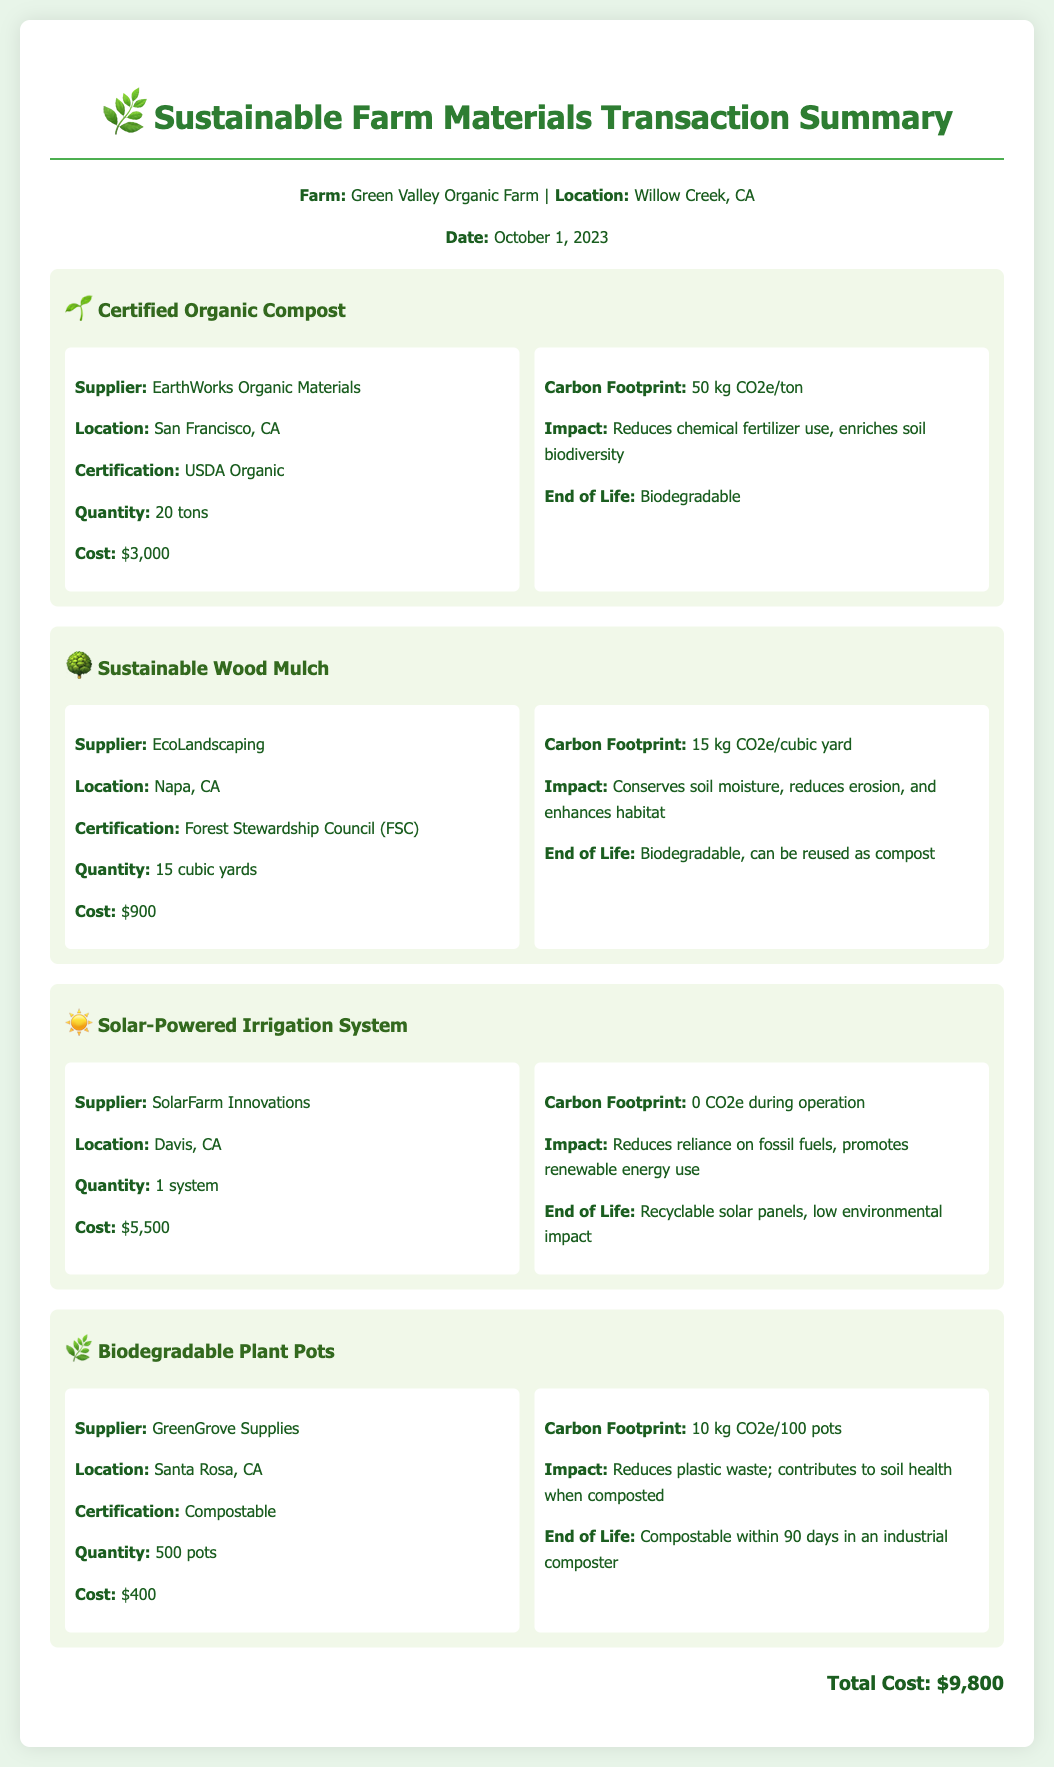what is the date of the transaction? The date mentioned in the document is October 1, 2023.
Answer: October 1, 2023 who is the supplier for Certified Organic Compost? The supplier listed for Certified Organic Compost is EarthWorks Organic Materials.
Answer: EarthWorks Organic Materials how much did the Solar-Powered Irrigation System cost? The document states that the cost for the Solar-Powered Irrigation System is $5,500.
Answer: $5,500 what is the carbon footprint of Sustainable Wood Mulch? The carbon footprint listed for Sustainable Wood Mulch is 15 kg CO2e/cubic yard.
Answer: 15 kg CO2e/cubic yard what is the total cost of materials purchased? The total cost is the sum of the individual costs listed for each item in the document, which amounts to $9,800.
Answer: $9,800 what is the environmental impact of the Biodegradable Plant Pots? The impact mentioned for the Biodegradable Plant Pots is that they reduce plastic waste and contribute to soil health when composted.
Answer: Reduces plastic waste; contributes to soil health when composted where is EcoLandscaping located? The location of EcoLandscaping, the supplier for Sustainable Wood Mulch, is Napa, CA.
Answer: Napa, CA how many pots were purchased for Biodegradable Plant Pots? The document specifies that the quantity of Biodegradable Plant Pots purchased is 500.
Answer: 500 